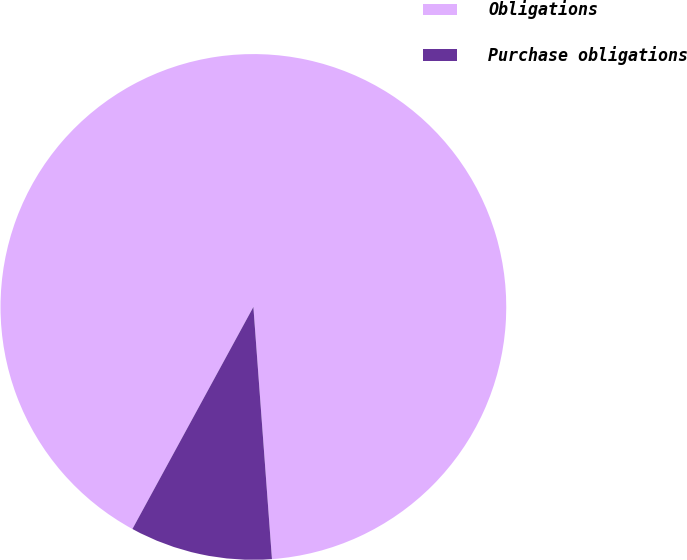Convert chart. <chart><loc_0><loc_0><loc_500><loc_500><pie_chart><fcel>Obligations<fcel>Purchase obligations<nl><fcel>90.89%<fcel>9.11%<nl></chart> 